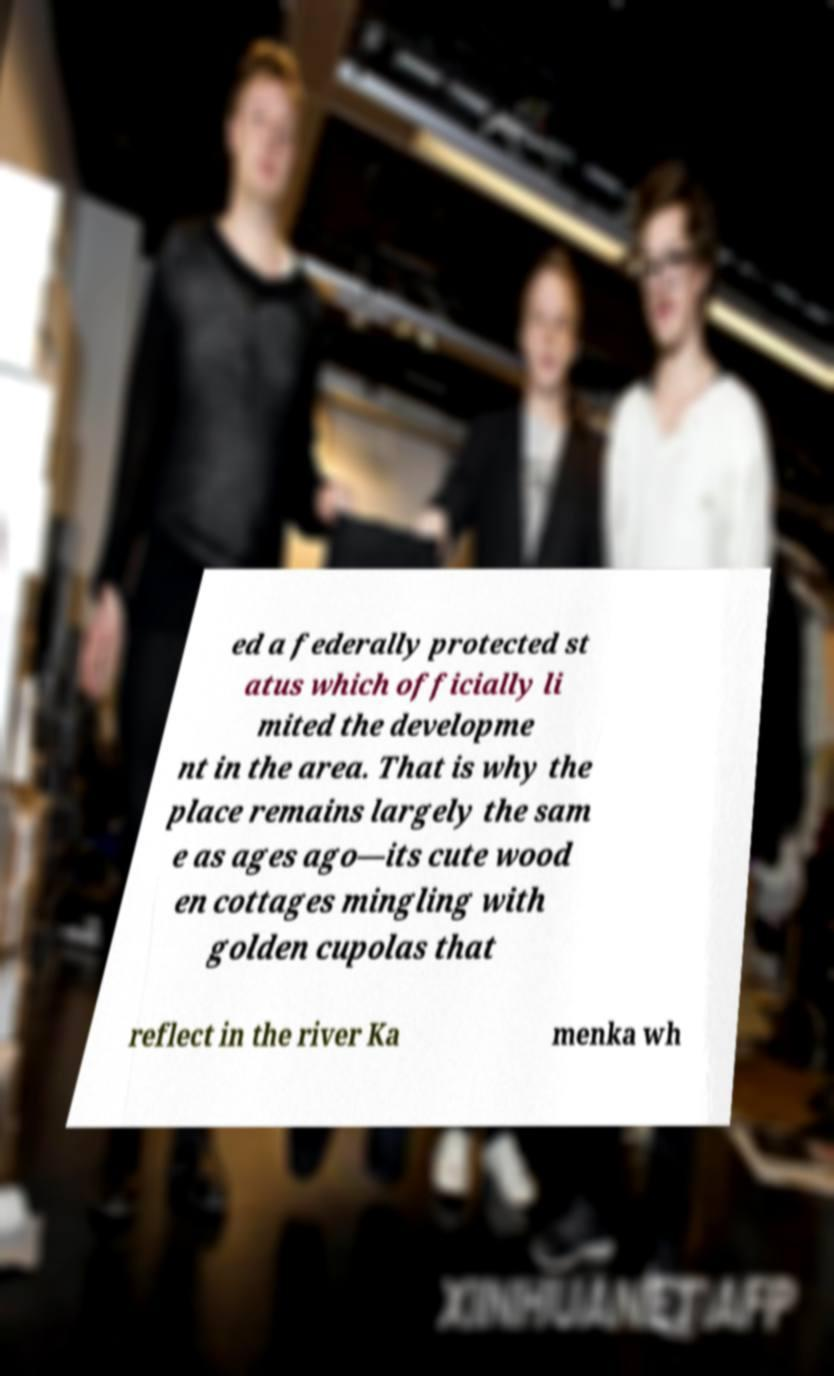Can you read and provide the text displayed in the image?This photo seems to have some interesting text. Can you extract and type it out for me? ed a federally protected st atus which officially li mited the developme nt in the area. That is why the place remains largely the sam e as ages ago—its cute wood en cottages mingling with golden cupolas that reflect in the river Ka menka wh 